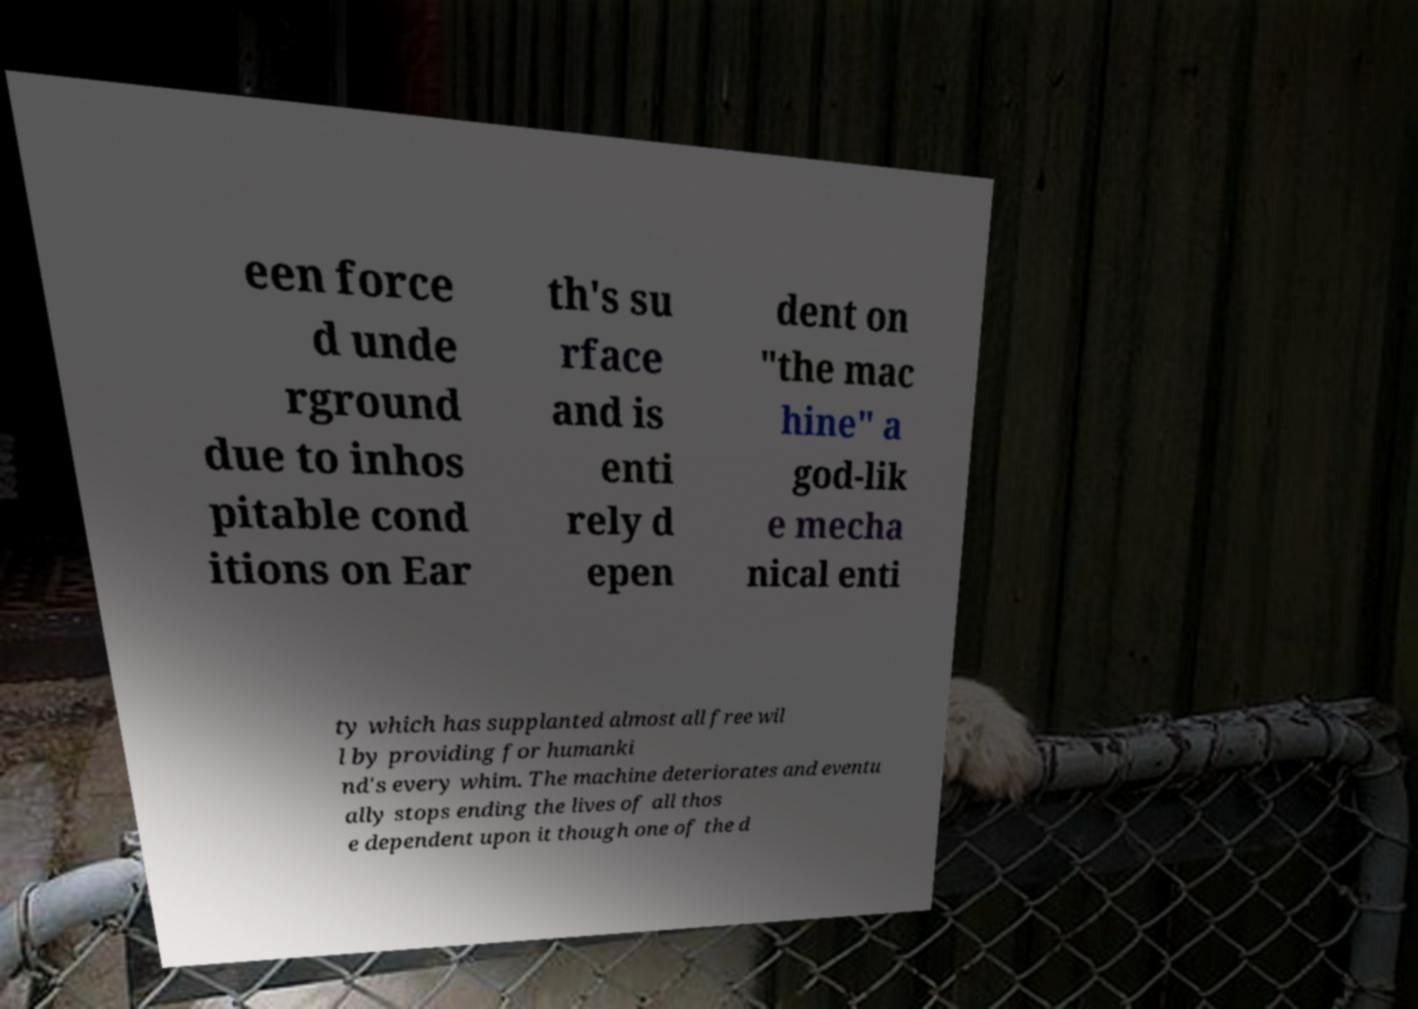Could you extract and type out the text from this image? een force d unde rground due to inhos pitable cond itions on Ear th's su rface and is enti rely d epen dent on "the mac hine" a god-lik e mecha nical enti ty which has supplanted almost all free wil l by providing for humanki nd's every whim. The machine deteriorates and eventu ally stops ending the lives of all thos e dependent upon it though one of the d 